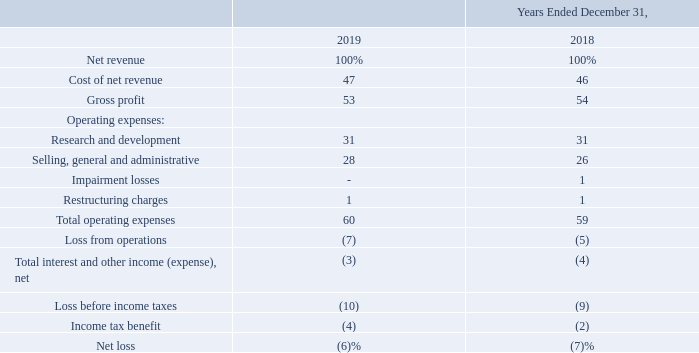Results of Operations
The following describes the line items set forth in our consolidated statements of operations. A discussion of changes in our results of operations during the year ended December 31, 2018 compared to the year ended December 31, 2017 has been omitted from this Annual Report on Form 10-K, but may be found in “Item 7.
Management’s Discussion and Analysis of Financial Condition and Results of Operations” in our Annual Report on Form 10-K for the year ended December 31, 2018, filed with the SEC on February 5, 2019, which discussion is incorporated herein by reference and which is available free of charge on the SEC’s website at www.sec.gov.
Net Revenue. Net revenue is generated from sales of radio-frequency, analog and mixed-signal integrated circuits for the connected home, wired and wireless infrastructure, and industrial and multi-market applications. A significant portion of our sales are to distributors, which then resell our products.
Cost of Net Revenue. Cost of net revenue includes the cost of finished silicon wafers processed by third-party foundries; costs associated with our outsourced packaging and assembly, test and shipping; costs of personnel, including stock-based compensation, and equipment associated with manufacturing support, logistics and quality assurance; amortization of acquired developed technology intangible assets and inventory step-ups to fair value; amortization of certain production mask costs; cost of production load boards and sockets; and an allocated portion of our occupancy costs.
Research and Development. Research and development expense includes personnel-related expenses, including stock-based compensation, new product engineering mask costs, prototype integrated circuit packaging and test costs, computer-aided design software license costs, intellectual property license costs, reference design development costs, development testing and evaluation costs, depreciation expense and allocated occupancy costs.
Research and development activities include the design of new products, refinement of existing products and design of test methodologies to ensure compliance with required specifications. All research and development costs are expensed as incurred.
Selling, General and Administrative. Selling, general and administrative expense includes personnel-related expenses, including stock-based compensation, amortization of certain acquired intangible assets, third-party sales commissions, field application engineering support, travel costs, professional and consulting fees, legal fees, depreciation expense and allocated occupancy costs. Impairment Losses. Impairment losses consist of charges resulting from the impairment of acquired intangible assets.
Restructuring Charges. Restructuring charges consist of severance, lease and leasehold impairment charges, and other charges related to restructuring plans. Interest and Other Income (Expense), Net. Interest and other income (expense), net includes interest income, interest expense and other income (expense). Interest income consists of interest earned on our cash, cash equivalents and restricted cash balances. Interest expense consists of interest accrued on debt. Other income (expense) generally consists of income (expense) generated from non-operating transactions.
Income Tax Provision (Benefit). We make certain estimates and judgments in determining income tax expense for financial statement purposes. These estimates and judgments occur in the calculation of certain tax assets and liabilities, which arise from differences in the timing of recognition of revenue and expenses for tax and financial statement purposes and the realizability of assets in future years.
The following table sets forth our consolidated statement of operations data as a percentage of net revenue for the periods indicated:
What are research and development activities? The design of new products, refinement of existing products and design of test methodologies to ensure compliance with required specifications. What is the average Cost of net revenue, for the Years Ended December 31, 2019 to 2018?
Answer scale should be: percent. (47+46) / 2
Answer: 46.5. What is the average Operating expenses: Selling, general and administrative, for the Years Ended December 31, 2019 to 2018?
Answer scale should be: percent. (28+26) / 2
Answer: 27. What is the average Loss from operations for the Years Ended December 31, 2019 to 2018?
Answer scale should be: percent. (7+5) / 2
Answer: 6. What are the Research and development expense? Personnel-related expenses, including stock-based compensation, new product engineering mask costs, prototype integrated circuit packaging and test costs, computer-aided design software license costs, intellectual property license costs, reference design development costs, development testing and evaluation costs, depreciation expense and allocated occupancy costs. What are Restructuring Charges? Consist of severance, lease and leasehold impairment charges, and other charges related to restructuring plans. 